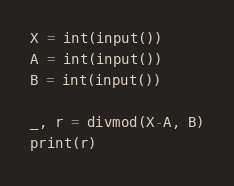<code> <loc_0><loc_0><loc_500><loc_500><_Python_>X = int(input())
A = int(input())
B = int(input())

_, r = divmod(X-A, B)
print(r)
</code> 